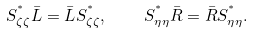<formula> <loc_0><loc_0><loc_500><loc_500>S _ { \zeta \zeta } ^ { ^ { * } } { \bar { L } } = { \bar { L } } S _ { \zeta \zeta } ^ { ^ { * } } , \quad S _ { \eta \eta } ^ { ^ { * } } { \bar { R } } = { \bar { R } } S _ { \eta \eta } ^ { ^ { * } } .</formula> 